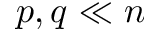<formula> <loc_0><loc_0><loc_500><loc_500>p , q \ll n</formula> 